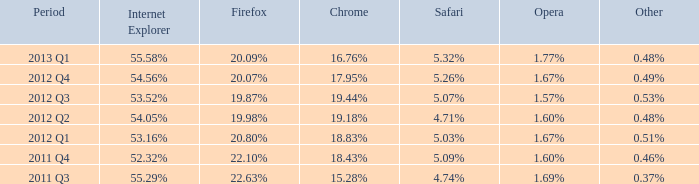Which web browser has 53.16%. Give me the full table as a dictionary. {'header': ['Period', 'Internet Explorer', 'Firefox', 'Chrome', 'Safari', 'Opera', 'Other'], 'rows': [['2013 Q1', '55.58%', '20.09%', '16.76%', '5.32%', '1.77%', '0.48%'], ['2012 Q4', '54.56%', '20.07%', '17.95%', '5.26%', '1.67%', '0.49%'], ['2012 Q3', '53.52%', '19.87%', '19.44%', '5.07%', '1.57%', '0.53%'], ['2012 Q2', '54.05%', '19.98%', '19.18%', '4.71%', '1.60%', '0.48%'], ['2012 Q1', '53.16%', '20.80%', '18.83%', '5.03%', '1.67%', '0.51%'], ['2011 Q4', '52.32%', '22.10%', '18.43%', '5.09%', '1.60%', '0.46%'], ['2011 Q3', '55.29%', '22.63%', '15.28%', '4.74%', '1.69%', '0.37%']]} 